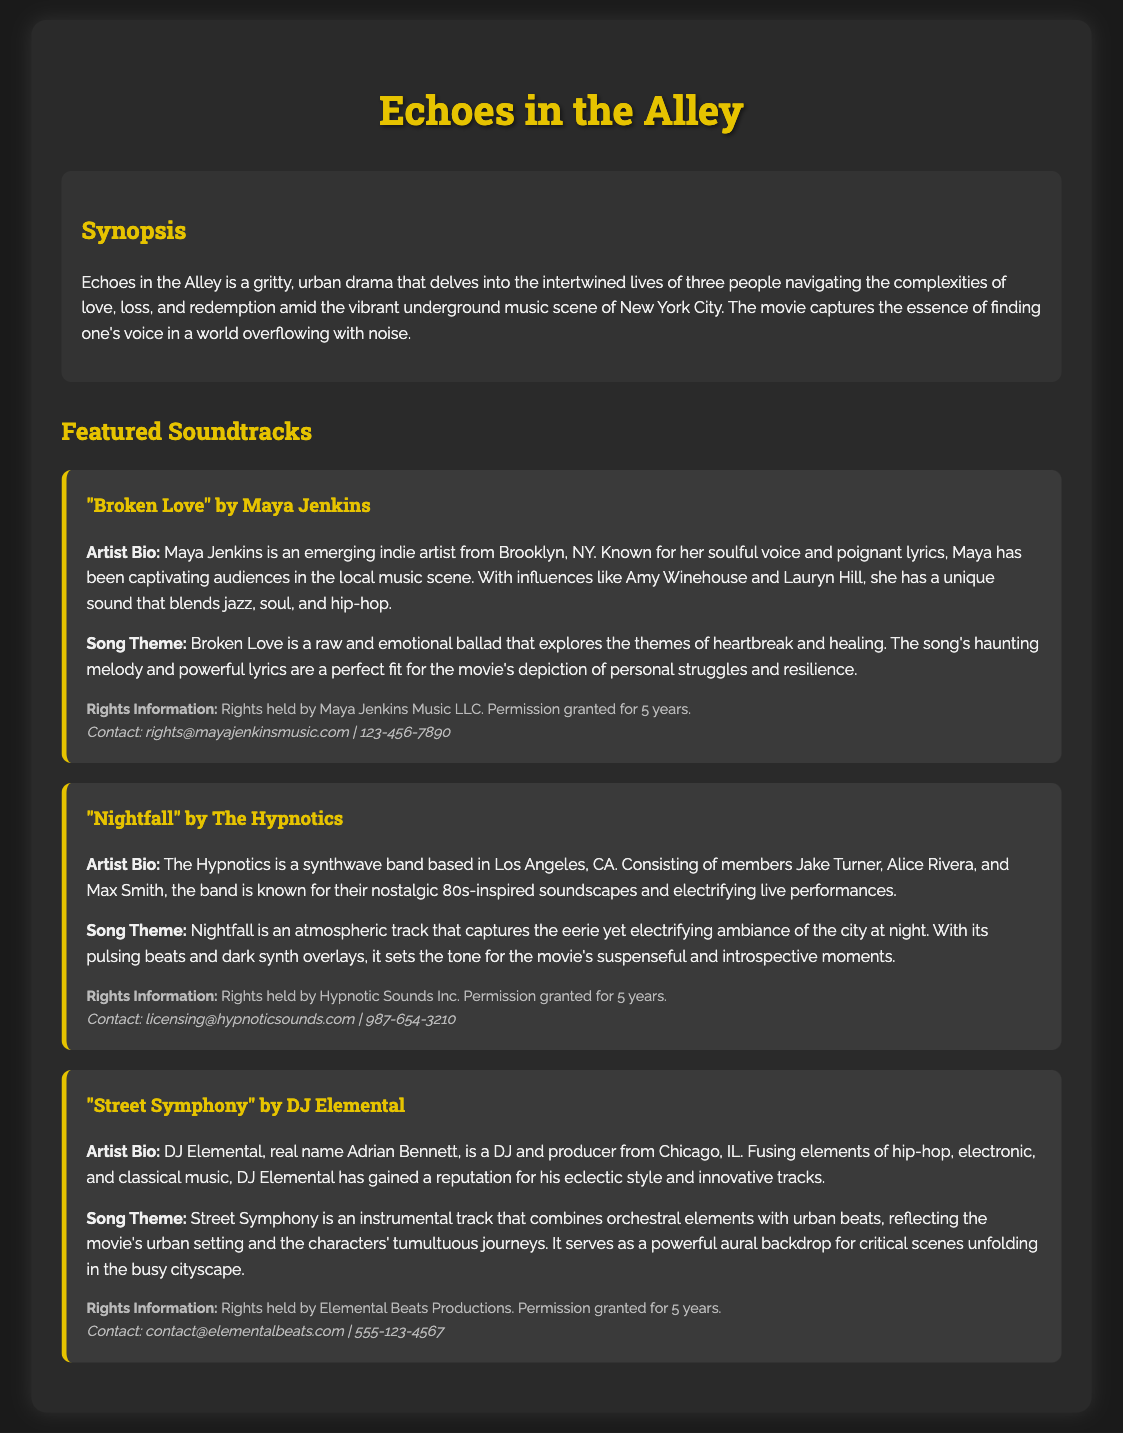What is the title of the movie? The title of the movie is mentioned prominently as "Echoes in the Alley" at the beginning of the document.
Answer: Echoes in the Alley Who is the artist of the song "Broken Love"? The artist associated with the song "Broken Love" is specified in the document as Maya Jenkins.
Answer: Maya Jenkins How long is the permission granted for rights usage? The duration for which permission is granted for rights usage is explicitly stated as 5 years in each rights information section.
Answer: 5 years What is the genre of DJ Elemental's music? The document describes DJ Elemental's music as a fusion of hip-hop, electronic, and classical genres.
Answer: Hip-hop, electronic, classical What city is The Hypnotics based in? The document specifies that The Hypnotics is based in Los Angeles, CA.
Answer: Los Angeles, CA What theme does the song "Nightfall" capture? The theme of the song "Nightfall" focuses on the eerie and electrifying ambiance of the city at night, as outlined in its description.
Answer: Eerie ambiance of the city at night Which song explores themes of heartbreak and healing? The song that explores themes of heartbreak and healing is identified as "Broken Love" in the document.
Answer: Broken Love Who is the contact person for rights information regarding DJ Elemental? The document provides the contact information for DJ Elemental as contact@elementalbeats.com.
Answer: contact@elementalbeats.com What kind of track is "Street Symphony"? The document indicates that "Street Symphony" is an instrumental track, combining orchestral elements with urban beats.
Answer: Instrumental track 